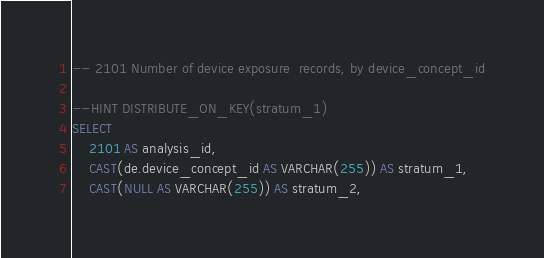<code> <loc_0><loc_0><loc_500><loc_500><_SQL_>-- 2101	Number of device exposure  records, by device_concept_id

--HINT DISTRIBUTE_ON_KEY(stratum_1)
SELECT 
	2101 AS analysis_id,
	CAST(de.device_concept_id AS VARCHAR(255)) AS stratum_1,
	CAST(NULL AS VARCHAR(255)) AS stratum_2,</code> 